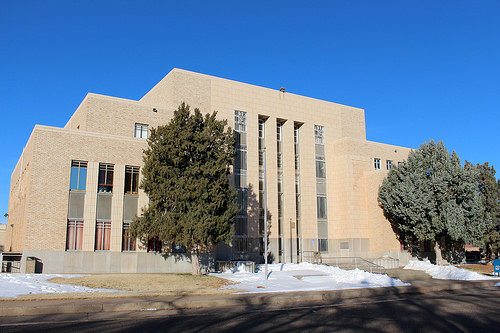<image>
Can you confirm if the tree is behind the window? No. The tree is not behind the window. From this viewpoint, the tree appears to be positioned elsewhere in the scene. 